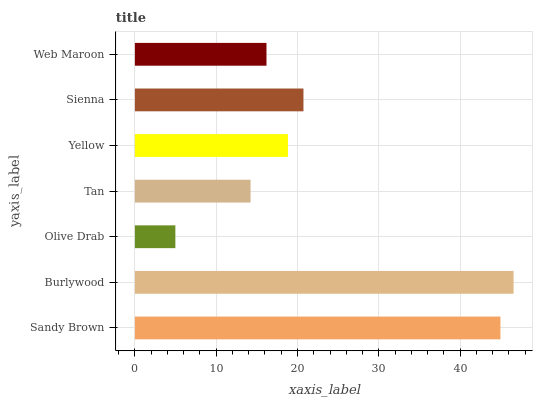Is Olive Drab the minimum?
Answer yes or no. Yes. Is Burlywood the maximum?
Answer yes or no. Yes. Is Burlywood the minimum?
Answer yes or no. No. Is Olive Drab the maximum?
Answer yes or no. No. Is Burlywood greater than Olive Drab?
Answer yes or no. Yes. Is Olive Drab less than Burlywood?
Answer yes or no. Yes. Is Olive Drab greater than Burlywood?
Answer yes or no. No. Is Burlywood less than Olive Drab?
Answer yes or no. No. Is Yellow the high median?
Answer yes or no. Yes. Is Yellow the low median?
Answer yes or no. Yes. Is Olive Drab the high median?
Answer yes or no. No. Is Tan the low median?
Answer yes or no. No. 